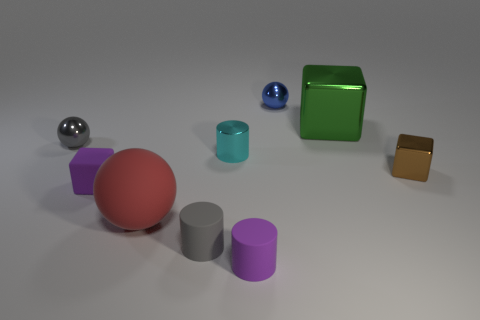How many objects are tiny purple objects in front of the purple block or metallic objects that are in front of the cyan metallic thing? In the image, there are no tiny purple objects directly in front of the purple block. There are two metallic objects in front of the cyan metallic cylinder: one silver metallic sphere and one smaller blue metallic sphere. 